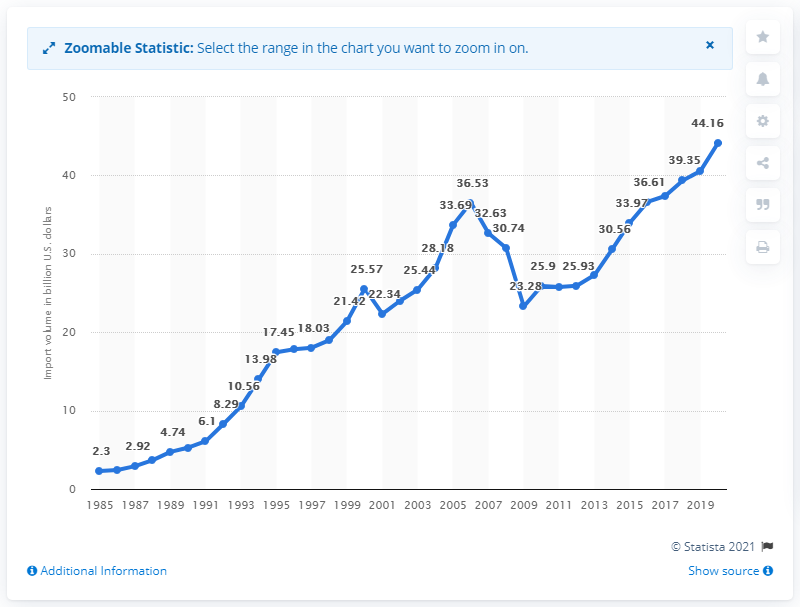Point out several critical features in this image. In 2020, the value of imports from Malaysia was 44.16 (dollars). 